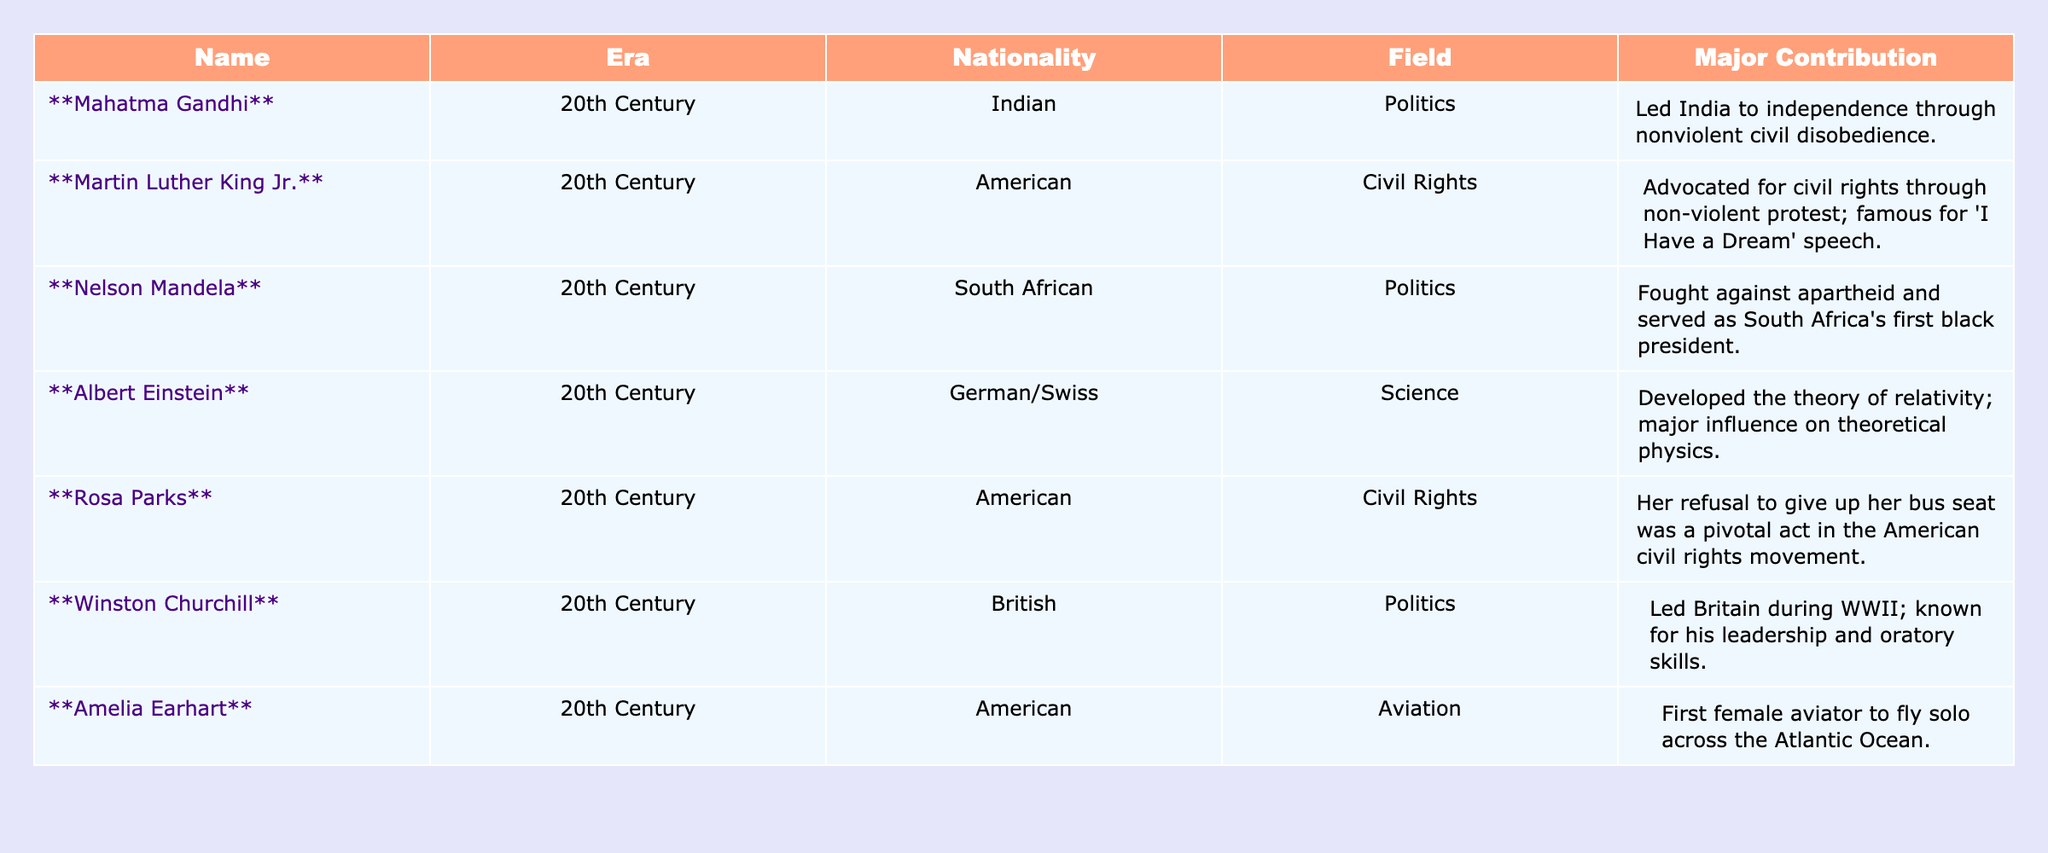What was the major contribution of Mahatma Gandhi? Mahatma Gandhi led India to independence through nonviolent civil disobedience, which is explicitly stated in the table under his major contribution.
Answer: Led India to independence through nonviolent civil disobedience Which figure is noted for advocating civil rights through non-violent protest? The table indicates that Martin Luther King Jr. advocated for civil rights through non-violent protest, making him the figure in question.
Answer: Martin Luther King Jr True or False: Amelia Earhart was the first female aviator to fly solo across the Atlantic Ocean. The table confirms that Amelia Earhart's major contribution is being the first female aviator to fly solo across the Atlantic Ocean, thus this statement is true.
Answer: True Who among the listed figures served as a president? According to the table, Nelson Mandela is noted as the first black president of South Africa, so he is the answer to this question.
Answer: Nelson Mandela How many figures in the table were involved in the field of politics? The individuals listed under the politics field are Mahatma Gandhi, Nelson Mandela, Winston Churchill, making a total of three figures.
Answer: 3 Which figure has a major contribution mentioned in the field of aviation? Scanning the table, it is clear that Amelia Earhart's contribution relates to aviation, specifically as the first female aviator to fly solo across the Atlantic Ocean.
Answer: Amelia Earhart What is the average era of the influential figures listed? All figures belong to the 20th Century; therefore, the average era is simply the same, 20th Century, since they all fall within this single era.
Answer: 20th Century Which influential figure is most associated with the struggle against apartheid? The table states that Nelson Mandela fought against apartheid, making him the most associated figure with that struggle.
Answer: Nelson Mandela What is the nationality of Rosa Parks? Referring to the table, it is clearly stated that Rosa Parks is American, indicating her nationality.
Answer: American Based on the table, which influential figure was known for their oratory skills during World War II? The table points to Winston Churchill as the figure known for his leadership and oratory skills during World War II, which answers this question.
Answer: Winston Churchill 